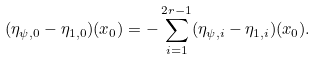<formula> <loc_0><loc_0><loc_500><loc_500>( \eta _ { \psi , 0 } - \eta _ { 1 , 0 } ) ( x _ { 0 } ) = - \sum _ { i = 1 } ^ { 2 r - 1 } ( \eta _ { \psi , i } - \eta _ { 1 , i } ) ( x _ { 0 } ) .</formula> 